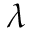Convert formula to latex. <formula><loc_0><loc_0><loc_500><loc_500>\lambda</formula> 